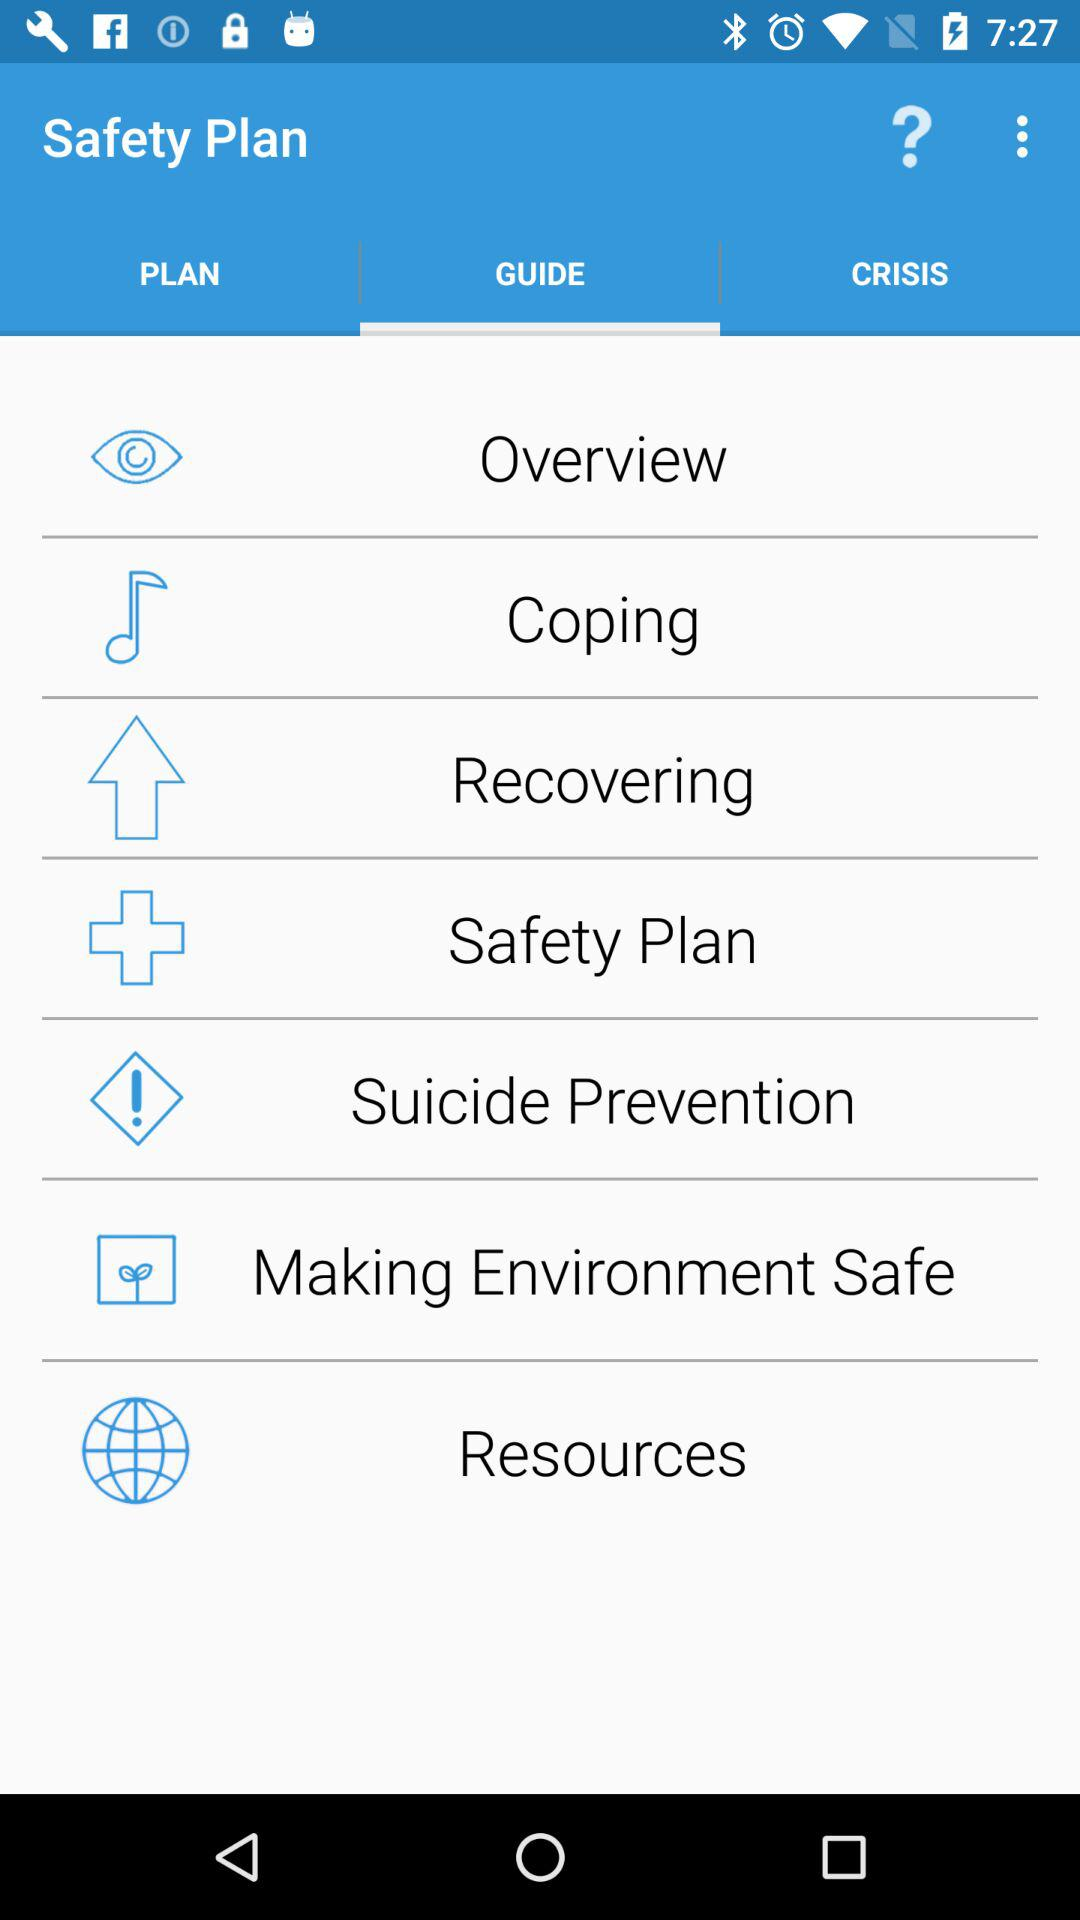What is the name of the application? The name of the application is "Safety Plan". 